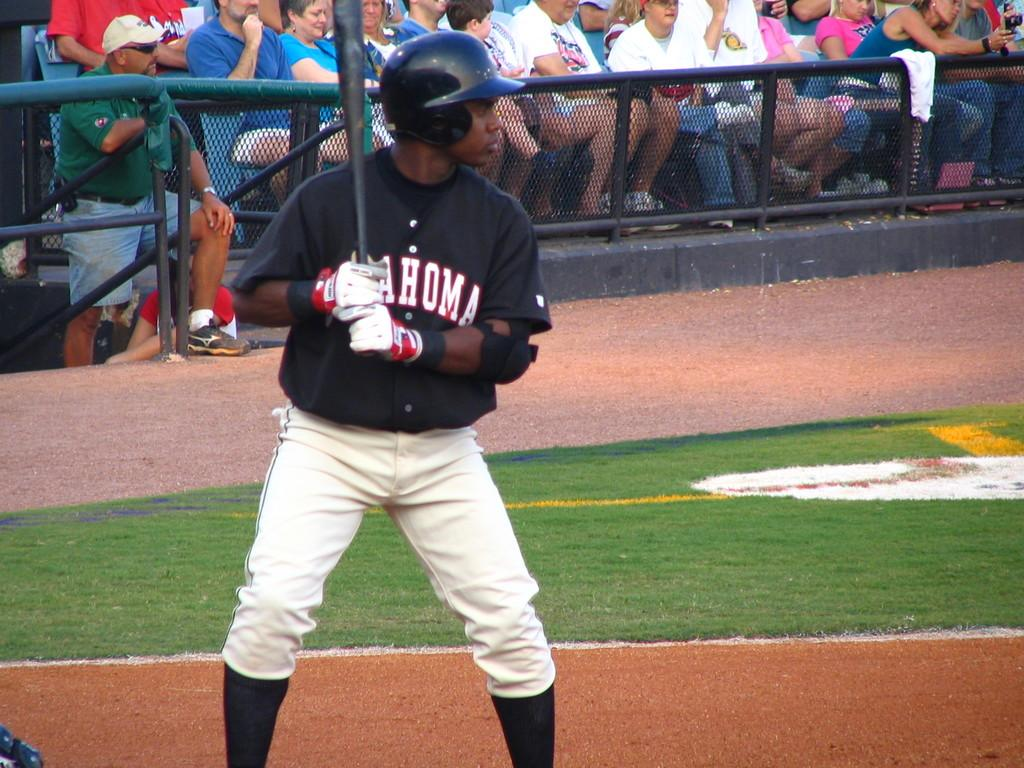<image>
Provide a brief description of the given image. A young man in a black jersey that says Ahoma on the front gets ready to bat. 